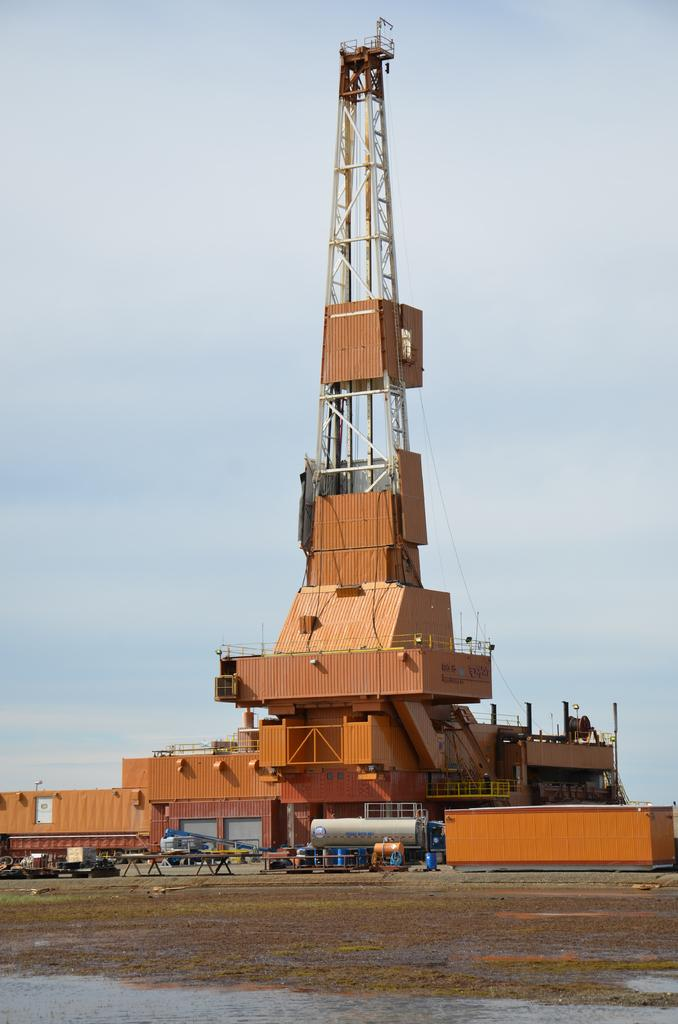What type of structure is located at the bottom of the image? There is a building at the bottom of the image. What feature is added to the building in the image? There is a tower placed on the building. What can be seen at the top of the image? The sky is visible at the top of the image. What type of mass is present in the image? There is no mass mentioned or visible in the image. What is the weather like in the image? The provided facts do not mention or show any weather conditions in the image. 